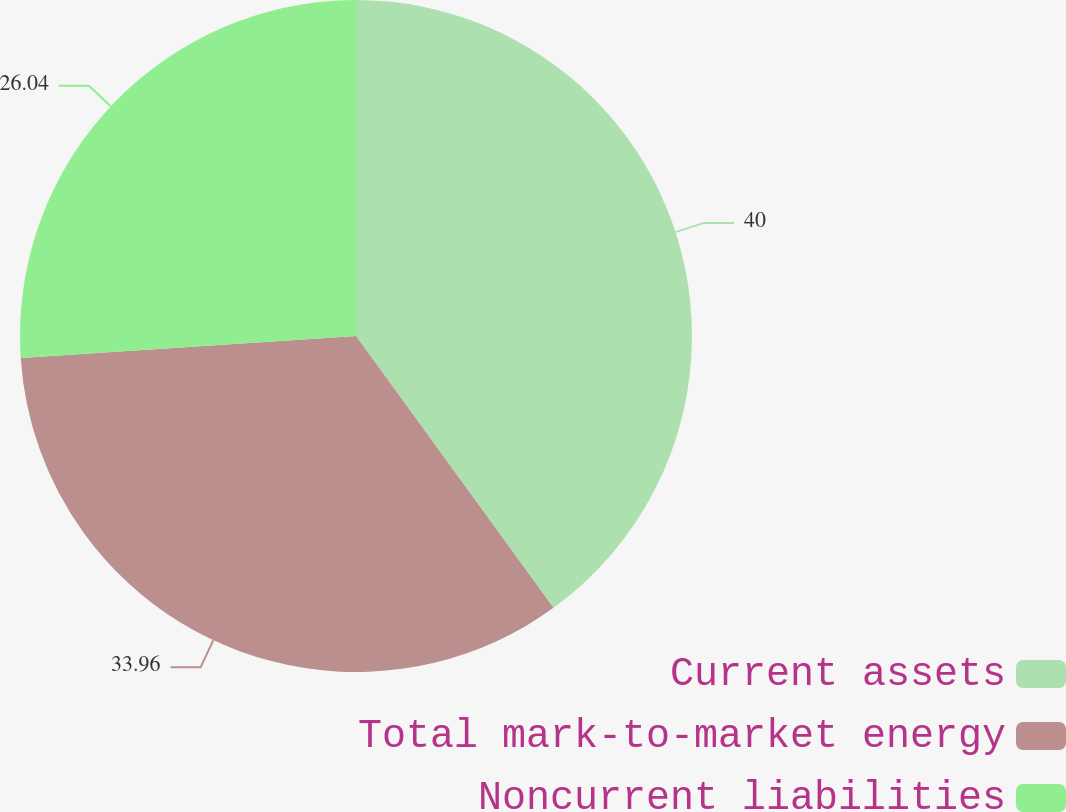Convert chart to OTSL. <chart><loc_0><loc_0><loc_500><loc_500><pie_chart><fcel>Current assets<fcel>Total mark-to-market energy<fcel>Noncurrent liabilities<nl><fcel>40.0%<fcel>33.96%<fcel>26.04%<nl></chart> 